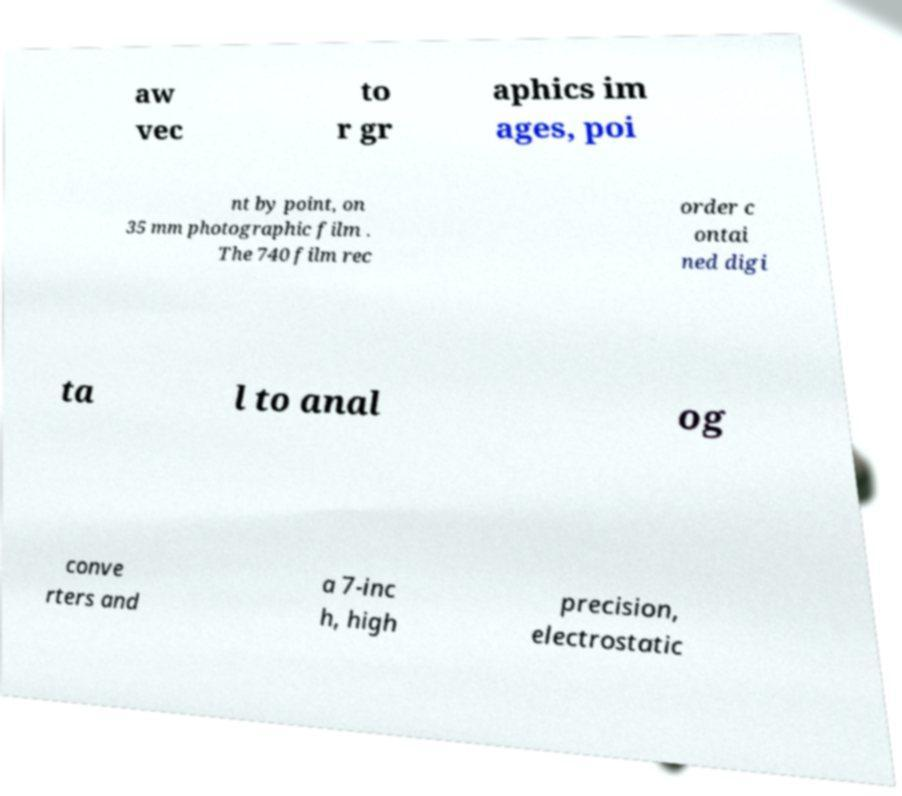Please identify and transcribe the text found in this image. aw vec to r gr aphics im ages, poi nt by point, on 35 mm photographic film . The 740 film rec order c ontai ned digi ta l to anal og conve rters and a 7-inc h, high precision, electrostatic 